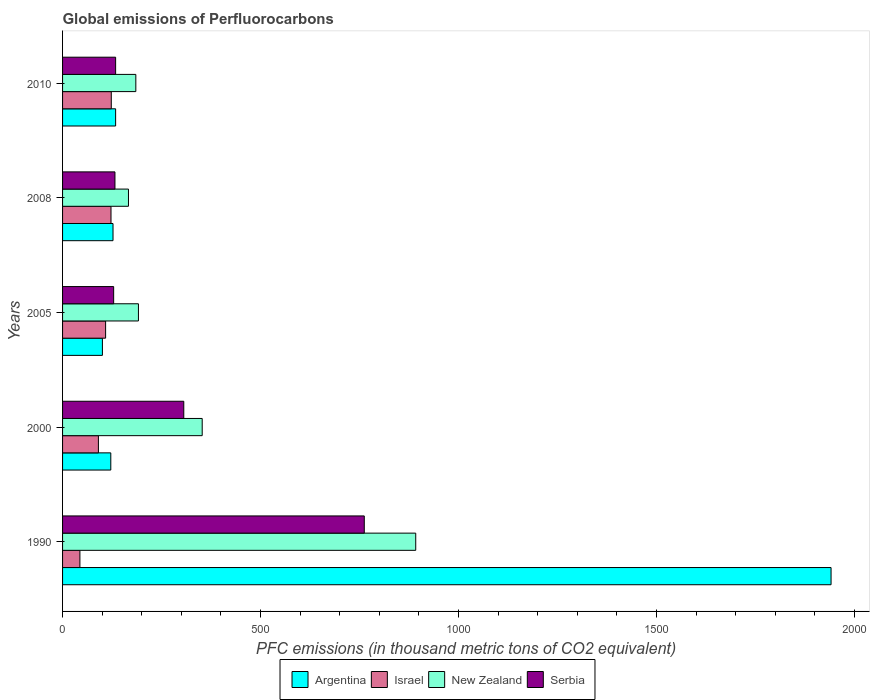Are the number of bars on each tick of the Y-axis equal?
Provide a short and direct response. Yes. What is the label of the 3rd group of bars from the top?
Give a very brief answer. 2005. What is the global emissions of Perfluorocarbons in New Zealand in 2000?
Your answer should be compact. 352.6. Across all years, what is the maximum global emissions of Perfluorocarbons in Argentina?
Make the answer very short. 1940.6. Across all years, what is the minimum global emissions of Perfluorocarbons in New Zealand?
Make the answer very short. 166.4. In which year was the global emissions of Perfluorocarbons in Serbia minimum?
Provide a succinct answer. 2005. What is the total global emissions of Perfluorocarbons in Argentina in the graph?
Keep it short and to the point. 2424.4. What is the difference between the global emissions of Perfluorocarbons in New Zealand in 2008 and that in 2010?
Your answer should be very brief. -18.6. What is the difference between the global emissions of Perfluorocarbons in Israel in 1990 and the global emissions of Perfluorocarbons in New Zealand in 2010?
Ensure brevity in your answer.  -141.2. What is the average global emissions of Perfluorocarbons in Serbia per year?
Offer a terse response. 292.66. In the year 2005, what is the difference between the global emissions of Perfluorocarbons in Serbia and global emissions of Perfluorocarbons in Israel?
Give a very brief answer. 20.3. What is the ratio of the global emissions of Perfluorocarbons in Israel in 2000 to that in 2010?
Keep it short and to the point. 0.74. What is the difference between the highest and the second highest global emissions of Perfluorocarbons in Argentina?
Your answer should be compact. 1806.6. What is the difference between the highest and the lowest global emissions of Perfluorocarbons in New Zealand?
Provide a short and direct response. 725.4. Is it the case that in every year, the sum of the global emissions of Perfluorocarbons in Israel and global emissions of Perfluorocarbons in Argentina is greater than the sum of global emissions of Perfluorocarbons in New Zealand and global emissions of Perfluorocarbons in Serbia?
Give a very brief answer. No. What does the 1st bar from the top in 2010 represents?
Offer a terse response. Serbia. Are all the bars in the graph horizontal?
Provide a short and direct response. Yes. How many years are there in the graph?
Provide a succinct answer. 5. Are the values on the major ticks of X-axis written in scientific E-notation?
Your answer should be very brief. No. Does the graph contain any zero values?
Your answer should be compact. No. Does the graph contain grids?
Offer a very short reply. No. Where does the legend appear in the graph?
Ensure brevity in your answer.  Bottom center. How many legend labels are there?
Offer a terse response. 4. How are the legend labels stacked?
Provide a succinct answer. Horizontal. What is the title of the graph?
Offer a terse response. Global emissions of Perfluorocarbons. Does "Uruguay" appear as one of the legend labels in the graph?
Your response must be concise. No. What is the label or title of the X-axis?
Keep it short and to the point. PFC emissions (in thousand metric tons of CO2 equivalent). What is the PFC emissions (in thousand metric tons of CO2 equivalent) of Argentina in 1990?
Provide a succinct answer. 1940.6. What is the PFC emissions (in thousand metric tons of CO2 equivalent) in Israel in 1990?
Provide a succinct answer. 43.8. What is the PFC emissions (in thousand metric tons of CO2 equivalent) in New Zealand in 1990?
Your response must be concise. 891.8. What is the PFC emissions (in thousand metric tons of CO2 equivalent) in Serbia in 1990?
Provide a succinct answer. 761.9. What is the PFC emissions (in thousand metric tons of CO2 equivalent) of Argentina in 2000?
Offer a terse response. 121.8. What is the PFC emissions (in thousand metric tons of CO2 equivalent) in Israel in 2000?
Make the answer very short. 90.5. What is the PFC emissions (in thousand metric tons of CO2 equivalent) in New Zealand in 2000?
Your answer should be compact. 352.6. What is the PFC emissions (in thousand metric tons of CO2 equivalent) of Serbia in 2000?
Make the answer very short. 306.1. What is the PFC emissions (in thousand metric tons of CO2 equivalent) in Argentina in 2005?
Provide a short and direct response. 100.6. What is the PFC emissions (in thousand metric tons of CO2 equivalent) in Israel in 2005?
Ensure brevity in your answer.  108.7. What is the PFC emissions (in thousand metric tons of CO2 equivalent) of New Zealand in 2005?
Offer a terse response. 191.6. What is the PFC emissions (in thousand metric tons of CO2 equivalent) of Serbia in 2005?
Your response must be concise. 129. What is the PFC emissions (in thousand metric tons of CO2 equivalent) of Argentina in 2008?
Keep it short and to the point. 127.4. What is the PFC emissions (in thousand metric tons of CO2 equivalent) in Israel in 2008?
Your answer should be very brief. 122.3. What is the PFC emissions (in thousand metric tons of CO2 equivalent) in New Zealand in 2008?
Offer a terse response. 166.4. What is the PFC emissions (in thousand metric tons of CO2 equivalent) in Serbia in 2008?
Provide a succinct answer. 132.3. What is the PFC emissions (in thousand metric tons of CO2 equivalent) of Argentina in 2010?
Give a very brief answer. 134. What is the PFC emissions (in thousand metric tons of CO2 equivalent) in Israel in 2010?
Offer a very short reply. 123. What is the PFC emissions (in thousand metric tons of CO2 equivalent) of New Zealand in 2010?
Keep it short and to the point. 185. What is the PFC emissions (in thousand metric tons of CO2 equivalent) in Serbia in 2010?
Offer a very short reply. 134. Across all years, what is the maximum PFC emissions (in thousand metric tons of CO2 equivalent) of Argentina?
Give a very brief answer. 1940.6. Across all years, what is the maximum PFC emissions (in thousand metric tons of CO2 equivalent) in Israel?
Ensure brevity in your answer.  123. Across all years, what is the maximum PFC emissions (in thousand metric tons of CO2 equivalent) of New Zealand?
Provide a short and direct response. 891.8. Across all years, what is the maximum PFC emissions (in thousand metric tons of CO2 equivalent) in Serbia?
Offer a terse response. 761.9. Across all years, what is the minimum PFC emissions (in thousand metric tons of CO2 equivalent) of Argentina?
Provide a short and direct response. 100.6. Across all years, what is the minimum PFC emissions (in thousand metric tons of CO2 equivalent) of Israel?
Give a very brief answer. 43.8. Across all years, what is the minimum PFC emissions (in thousand metric tons of CO2 equivalent) of New Zealand?
Your answer should be compact. 166.4. Across all years, what is the minimum PFC emissions (in thousand metric tons of CO2 equivalent) of Serbia?
Provide a succinct answer. 129. What is the total PFC emissions (in thousand metric tons of CO2 equivalent) in Argentina in the graph?
Your response must be concise. 2424.4. What is the total PFC emissions (in thousand metric tons of CO2 equivalent) in Israel in the graph?
Keep it short and to the point. 488.3. What is the total PFC emissions (in thousand metric tons of CO2 equivalent) of New Zealand in the graph?
Provide a succinct answer. 1787.4. What is the total PFC emissions (in thousand metric tons of CO2 equivalent) of Serbia in the graph?
Your response must be concise. 1463.3. What is the difference between the PFC emissions (in thousand metric tons of CO2 equivalent) of Argentina in 1990 and that in 2000?
Keep it short and to the point. 1818.8. What is the difference between the PFC emissions (in thousand metric tons of CO2 equivalent) in Israel in 1990 and that in 2000?
Give a very brief answer. -46.7. What is the difference between the PFC emissions (in thousand metric tons of CO2 equivalent) of New Zealand in 1990 and that in 2000?
Ensure brevity in your answer.  539.2. What is the difference between the PFC emissions (in thousand metric tons of CO2 equivalent) in Serbia in 1990 and that in 2000?
Your response must be concise. 455.8. What is the difference between the PFC emissions (in thousand metric tons of CO2 equivalent) of Argentina in 1990 and that in 2005?
Give a very brief answer. 1840. What is the difference between the PFC emissions (in thousand metric tons of CO2 equivalent) of Israel in 1990 and that in 2005?
Offer a terse response. -64.9. What is the difference between the PFC emissions (in thousand metric tons of CO2 equivalent) in New Zealand in 1990 and that in 2005?
Keep it short and to the point. 700.2. What is the difference between the PFC emissions (in thousand metric tons of CO2 equivalent) in Serbia in 1990 and that in 2005?
Your response must be concise. 632.9. What is the difference between the PFC emissions (in thousand metric tons of CO2 equivalent) in Argentina in 1990 and that in 2008?
Offer a very short reply. 1813.2. What is the difference between the PFC emissions (in thousand metric tons of CO2 equivalent) in Israel in 1990 and that in 2008?
Your answer should be compact. -78.5. What is the difference between the PFC emissions (in thousand metric tons of CO2 equivalent) in New Zealand in 1990 and that in 2008?
Keep it short and to the point. 725.4. What is the difference between the PFC emissions (in thousand metric tons of CO2 equivalent) of Serbia in 1990 and that in 2008?
Provide a short and direct response. 629.6. What is the difference between the PFC emissions (in thousand metric tons of CO2 equivalent) in Argentina in 1990 and that in 2010?
Your answer should be compact. 1806.6. What is the difference between the PFC emissions (in thousand metric tons of CO2 equivalent) in Israel in 1990 and that in 2010?
Keep it short and to the point. -79.2. What is the difference between the PFC emissions (in thousand metric tons of CO2 equivalent) in New Zealand in 1990 and that in 2010?
Provide a succinct answer. 706.8. What is the difference between the PFC emissions (in thousand metric tons of CO2 equivalent) in Serbia in 1990 and that in 2010?
Offer a terse response. 627.9. What is the difference between the PFC emissions (in thousand metric tons of CO2 equivalent) in Argentina in 2000 and that in 2005?
Provide a succinct answer. 21.2. What is the difference between the PFC emissions (in thousand metric tons of CO2 equivalent) of Israel in 2000 and that in 2005?
Offer a very short reply. -18.2. What is the difference between the PFC emissions (in thousand metric tons of CO2 equivalent) of New Zealand in 2000 and that in 2005?
Keep it short and to the point. 161. What is the difference between the PFC emissions (in thousand metric tons of CO2 equivalent) in Serbia in 2000 and that in 2005?
Ensure brevity in your answer.  177.1. What is the difference between the PFC emissions (in thousand metric tons of CO2 equivalent) of Israel in 2000 and that in 2008?
Give a very brief answer. -31.8. What is the difference between the PFC emissions (in thousand metric tons of CO2 equivalent) in New Zealand in 2000 and that in 2008?
Your answer should be very brief. 186.2. What is the difference between the PFC emissions (in thousand metric tons of CO2 equivalent) of Serbia in 2000 and that in 2008?
Make the answer very short. 173.8. What is the difference between the PFC emissions (in thousand metric tons of CO2 equivalent) in Israel in 2000 and that in 2010?
Your answer should be very brief. -32.5. What is the difference between the PFC emissions (in thousand metric tons of CO2 equivalent) of New Zealand in 2000 and that in 2010?
Keep it short and to the point. 167.6. What is the difference between the PFC emissions (in thousand metric tons of CO2 equivalent) of Serbia in 2000 and that in 2010?
Your response must be concise. 172.1. What is the difference between the PFC emissions (in thousand metric tons of CO2 equivalent) in Argentina in 2005 and that in 2008?
Provide a succinct answer. -26.8. What is the difference between the PFC emissions (in thousand metric tons of CO2 equivalent) in New Zealand in 2005 and that in 2008?
Keep it short and to the point. 25.2. What is the difference between the PFC emissions (in thousand metric tons of CO2 equivalent) in Argentina in 2005 and that in 2010?
Provide a succinct answer. -33.4. What is the difference between the PFC emissions (in thousand metric tons of CO2 equivalent) of Israel in 2005 and that in 2010?
Keep it short and to the point. -14.3. What is the difference between the PFC emissions (in thousand metric tons of CO2 equivalent) in New Zealand in 2005 and that in 2010?
Keep it short and to the point. 6.6. What is the difference between the PFC emissions (in thousand metric tons of CO2 equivalent) of Serbia in 2005 and that in 2010?
Provide a short and direct response. -5. What is the difference between the PFC emissions (in thousand metric tons of CO2 equivalent) of Argentina in 2008 and that in 2010?
Keep it short and to the point. -6.6. What is the difference between the PFC emissions (in thousand metric tons of CO2 equivalent) of Israel in 2008 and that in 2010?
Your answer should be very brief. -0.7. What is the difference between the PFC emissions (in thousand metric tons of CO2 equivalent) in New Zealand in 2008 and that in 2010?
Offer a very short reply. -18.6. What is the difference between the PFC emissions (in thousand metric tons of CO2 equivalent) of Argentina in 1990 and the PFC emissions (in thousand metric tons of CO2 equivalent) of Israel in 2000?
Offer a very short reply. 1850.1. What is the difference between the PFC emissions (in thousand metric tons of CO2 equivalent) of Argentina in 1990 and the PFC emissions (in thousand metric tons of CO2 equivalent) of New Zealand in 2000?
Your answer should be compact. 1588. What is the difference between the PFC emissions (in thousand metric tons of CO2 equivalent) in Argentina in 1990 and the PFC emissions (in thousand metric tons of CO2 equivalent) in Serbia in 2000?
Offer a very short reply. 1634.5. What is the difference between the PFC emissions (in thousand metric tons of CO2 equivalent) of Israel in 1990 and the PFC emissions (in thousand metric tons of CO2 equivalent) of New Zealand in 2000?
Provide a short and direct response. -308.8. What is the difference between the PFC emissions (in thousand metric tons of CO2 equivalent) of Israel in 1990 and the PFC emissions (in thousand metric tons of CO2 equivalent) of Serbia in 2000?
Your answer should be very brief. -262.3. What is the difference between the PFC emissions (in thousand metric tons of CO2 equivalent) in New Zealand in 1990 and the PFC emissions (in thousand metric tons of CO2 equivalent) in Serbia in 2000?
Provide a short and direct response. 585.7. What is the difference between the PFC emissions (in thousand metric tons of CO2 equivalent) of Argentina in 1990 and the PFC emissions (in thousand metric tons of CO2 equivalent) of Israel in 2005?
Keep it short and to the point. 1831.9. What is the difference between the PFC emissions (in thousand metric tons of CO2 equivalent) of Argentina in 1990 and the PFC emissions (in thousand metric tons of CO2 equivalent) of New Zealand in 2005?
Your answer should be compact. 1749. What is the difference between the PFC emissions (in thousand metric tons of CO2 equivalent) of Argentina in 1990 and the PFC emissions (in thousand metric tons of CO2 equivalent) of Serbia in 2005?
Provide a succinct answer. 1811.6. What is the difference between the PFC emissions (in thousand metric tons of CO2 equivalent) of Israel in 1990 and the PFC emissions (in thousand metric tons of CO2 equivalent) of New Zealand in 2005?
Keep it short and to the point. -147.8. What is the difference between the PFC emissions (in thousand metric tons of CO2 equivalent) of Israel in 1990 and the PFC emissions (in thousand metric tons of CO2 equivalent) of Serbia in 2005?
Your answer should be very brief. -85.2. What is the difference between the PFC emissions (in thousand metric tons of CO2 equivalent) in New Zealand in 1990 and the PFC emissions (in thousand metric tons of CO2 equivalent) in Serbia in 2005?
Provide a succinct answer. 762.8. What is the difference between the PFC emissions (in thousand metric tons of CO2 equivalent) in Argentina in 1990 and the PFC emissions (in thousand metric tons of CO2 equivalent) in Israel in 2008?
Your response must be concise. 1818.3. What is the difference between the PFC emissions (in thousand metric tons of CO2 equivalent) in Argentina in 1990 and the PFC emissions (in thousand metric tons of CO2 equivalent) in New Zealand in 2008?
Offer a very short reply. 1774.2. What is the difference between the PFC emissions (in thousand metric tons of CO2 equivalent) of Argentina in 1990 and the PFC emissions (in thousand metric tons of CO2 equivalent) of Serbia in 2008?
Give a very brief answer. 1808.3. What is the difference between the PFC emissions (in thousand metric tons of CO2 equivalent) in Israel in 1990 and the PFC emissions (in thousand metric tons of CO2 equivalent) in New Zealand in 2008?
Give a very brief answer. -122.6. What is the difference between the PFC emissions (in thousand metric tons of CO2 equivalent) of Israel in 1990 and the PFC emissions (in thousand metric tons of CO2 equivalent) of Serbia in 2008?
Your answer should be compact. -88.5. What is the difference between the PFC emissions (in thousand metric tons of CO2 equivalent) of New Zealand in 1990 and the PFC emissions (in thousand metric tons of CO2 equivalent) of Serbia in 2008?
Your response must be concise. 759.5. What is the difference between the PFC emissions (in thousand metric tons of CO2 equivalent) of Argentina in 1990 and the PFC emissions (in thousand metric tons of CO2 equivalent) of Israel in 2010?
Your answer should be very brief. 1817.6. What is the difference between the PFC emissions (in thousand metric tons of CO2 equivalent) of Argentina in 1990 and the PFC emissions (in thousand metric tons of CO2 equivalent) of New Zealand in 2010?
Ensure brevity in your answer.  1755.6. What is the difference between the PFC emissions (in thousand metric tons of CO2 equivalent) in Argentina in 1990 and the PFC emissions (in thousand metric tons of CO2 equivalent) in Serbia in 2010?
Provide a short and direct response. 1806.6. What is the difference between the PFC emissions (in thousand metric tons of CO2 equivalent) of Israel in 1990 and the PFC emissions (in thousand metric tons of CO2 equivalent) of New Zealand in 2010?
Ensure brevity in your answer.  -141.2. What is the difference between the PFC emissions (in thousand metric tons of CO2 equivalent) in Israel in 1990 and the PFC emissions (in thousand metric tons of CO2 equivalent) in Serbia in 2010?
Your answer should be very brief. -90.2. What is the difference between the PFC emissions (in thousand metric tons of CO2 equivalent) in New Zealand in 1990 and the PFC emissions (in thousand metric tons of CO2 equivalent) in Serbia in 2010?
Provide a succinct answer. 757.8. What is the difference between the PFC emissions (in thousand metric tons of CO2 equivalent) in Argentina in 2000 and the PFC emissions (in thousand metric tons of CO2 equivalent) in Israel in 2005?
Your response must be concise. 13.1. What is the difference between the PFC emissions (in thousand metric tons of CO2 equivalent) of Argentina in 2000 and the PFC emissions (in thousand metric tons of CO2 equivalent) of New Zealand in 2005?
Offer a very short reply. -69.8. What is the difference between the PFC emissions (in thousand metric tons of CO2 equivalent) in Israel in 2000 and the PFC emissions (in thousand metric tons of CO2 equivalent) in New Zealand in 2005?
Offer a terse response. -101.1. What is the difference between the PFC emissions (in thousand metric tons of CO2 equivalent) of Israel in 2000 and the PFC emissions (in thousand metric tons of CO2 equivalent) of Serbia in 2005?
Provide a succinct answer. -38.5. What is the difference between the PFC emissions (in thousand metric tons of CO2 equivalent) in New Zealand in 2000 and the PFC emissions (in thousand metric tons of CO2 equivalent) in Serbia in 2005?
Give a very brief answer. 223.6. What is the difference between the PFC emissions (in thousand metric tons of CO2 equivalent) in Argentina in 2000 and the PFC emissions (in thousand metric tons of CO2 equivalent) in New Zealand in 2008?
Provide a short and direct response. -44.6. What is the difference between the PFC emissions (in thousand metric tons of CO2 equivalent) of Argentina in 2000 and the PFC emissions (in thousand metric tons of CO2 equivalent) of Serbia in 2008?
Offer a very short reply. -10.5. What is the difference between the PFC emissions (in thousand metric tons of CO2 equivalent) in Israel in 2000 and the PFC emissions (in thousand metric tons of CO2 equivalent) in New Zealand in 2008?
Provide a short and direct response. -75.9. What is the difference between the PFC emissions (in thousand metric tons of CO2 equivalent) of Israel in 2000 and the PFC emissions (in thousand metric tons of CO2 equivalent) of Serbia in 2008?
Make the answer very short. -41.8. What is the difference between the PFC emissions (in thousand metric tons of CO2 equivalent) of New Zealand in 2000 and the PFC emissions (in thousand metric tons of CO2 equivalent) of Serbia in 2008?
Provide a short and direct response. 220.3. What is the difference between the PFC emissions (in thousand metric tons of CO2 equivalent) in Argentina in 2000 and the PFC emissions (in thousand metric tons of CO2 equivalent) in New Zealand in 2010?
Provide a succinct answer. -63.2. What is the difference between the PFC emissions (in thousand metric tons of CO2 equivalent) of Israel in 2000 and the PFC emissions (in thousand metric tons of CO2 equivalent) of New Zealand in 2010?
Your response must be concise. -94.5. What is the difference between the PFC emissions (in thousand metric tons of CO2 equivalent) of Israel in 2000 and the PFC emissions (in thousand metric tons of CO2 equivalent) of Serbia in 2010?
Your answer should be very brief. -43.5. What is the difference between the PFC emissions (in thousand metric tons of CO2 equivalent) in New Zealand in 2000 and the PFC emissions (in thousand metric tons of CO2 equivalent) in Serbia in 2010?
Your response must be concise. 218.6. What is the difference between the PFC emissions (in thousand metric tons of CO2 equivalent) of Argentina in 2005 and the PFC emissions (in thousand metric tons of CO2 equivalent) of Israel in 2008?
Give a very brief answer. -21.7. What is the difference between the PFC emissions (in thousand metric tons of CO2 equivalent) of Argentina in 2005 and the PFC emissions (in thousand metric tons of CO2 equivalent) of New Zealand in 2008?
Give a very brief answer. -65.8. What is the difference between the PFC emissions (in thousand metric tons of CO2 equivalent) of Argentina in 2005 and the PFC emissions (in thousand metric tons of CO2 equivalent) of Serbia in 2008?
Your answer should be compact. -31.7. What is the difference between the PFC emissions (in thousand metric tons of CO2 equivalent) in Israel in 2005 and the PFC emissions (in thousand metric tons of CO2 equivalent) in New Zealand in 2008?
Provide a short and direct response. -57.7. What is the difference between the PFC emissions (in thousand metric tons of CO2 equivalent) in Israel in 2005 and the PFC emissions (in thousand metric tons of CO2 equivalent) in Serbia in 2008?
Provide a short and direct response. -23.6. What is the difference between the PFC emissions (in thousand metric tons of CO2 equivalent) in New Zealand in 2005 and the PFC emissions (in thousand metric tons of CO2 equivalent) in Serbia in 2008?
Provide a succinct answer. 59.3. What is the difference between the PFC emissions (in thousand metric tons of CO2 equivalent) of Argentina in 2005 and the PFC emissions (in thousand metric tons of CO2 equivalent) of Israel in 2010?
Ensure brevity in your answer.  -22.4. What is the difference between the PFC emissions (in thousand metric tons of CO2 equivalent) in Argentina in 2005 and the PFC emissions (in thousand metric tons of CO2 equivalent) in New Zealand in 2010?
Your response must be concise. -84.4. What is the difference between the PFC emissions (in thousand metric tons of CO2 equivalent) of Argentina in 2005 and the PFC emissions (in thousand metric tons of CO2 equivalent) of Serbia in 2010?
Provide a succinct answer. -33.4. What is the difference between the PFC emissions (in thousand metric tons of CO2 equivalent) of Israel in 2005 and the PFC emissions (in thousand metric tons of CO2 equivalent) of New Zealand in 2010?
Make the answer very short. -76.3. What is the difference between the PFC emissions (in thousand metric tons of CO2 equivalent) of Israel in 2005 and the PFC emissions (in thousand metric tons of CO2 equivalent) of Serbia in 2010?
Offer a terse response. -25.3. What is the difference between the PFC emissions (in thousand metric tons of CO2 equivalent) in New Zealand in 2005 and the PFC emissions (in thousand metric tons of CO2 equivalent) in Serbia in 2010?
Your response must be concise. 57.6. What is the difference between the PFC emissions (in thousand metric tons of CO2 equivalent) of Argentina in 2008 and the PFC emissions (in thousand metric tons of CO2 equivalent) of New Zealand in 2010?
Provide a succinct answer. -57.6. What is the difference between the PFC emissions (in thousand metric tons of CO2 equivalent) in Argentina in 2008 and the PFC emissions (in thousand metric tons of CO2 equivalent) in Serbia in 2010?
Offer a very short reply. -6.6. What is the difference between the PFC emissions (in thousand metric tons of CO2 equivalent) of Israel in 2008 and the PFC emissions (in thousand metric tons of CO2 equivalent) of New Zealand in 2010?
Keep it short and to the point. -62.7. What is the difference between the PFC emissions (in thousand metric tons of CO2 equivalent) in New Zealand in 2008 and the PFC emissions (in thousand metric tons of CO2 equivalent) in Serbia in 2010?
Your answer should be very brief. 32.4. What is the average PFC emissions (in thousand metric tons of CO2 equivalent) in Argentina per year?
Ensure brevity in your answer.  484.88. What is the average PFC emissions (in thousand metric tons of CO2 equivalent) in Israel per year?
Your answer should be very brief. 97.66. What is the average PFC emissions (in thousand metric tons of CO2 equivalent) in New Zealand per year?
Your answer should be very brief. 357.48. What is the average PFC emissions (in thousand metric tons of CO2 equivalent) of Serbia per year?
Offer a terse response. 292.66. In the year 1990, what is the difference between the PFC emissions (in thousand metric tons of CO2 equivalent) of Argentina and PFC emissions (in thousand metric tons of CO2 equivalent) of Israel?
Keep it short and to the point. 1896.8. In the year 1990, what is the difference between the PFC emissions (in thousand metric tons of CO2 equivalent) in Argentina and PFC emissions (in thousand metric tons of CO2 equivalent) in New Zealand?
Make the answer very short. 1048.8. In the year 1990, what is the difference between the PFC emissions (in thousand metric tons of CO2 equivalent) in Argentina and PFC emissions (in thousand metric tons of CO2 equivalent) in Serbia?
Provide a short and direct response. 1178.7. In the year 1990, what is the difference between the PFC emissions (in thousand metric tons of CO2 equivalent) of Israel and PFC emissions (in thousand metric tons of CO2 equivalent) of New Zealand?
Your answer should be very brief. -848. In the year 1990, what is the difference between the PFC emissions (in thousand metric tons of CO2 equivalent) of Israel and PFC emissions (in thousand metric tons of CO2 equivalent) of Serbia?
Your answer should be very brief. -718.1. In the year 1990, what is the difference between the PFC emissions (in thousand metric tons of CO2 equivalent) of New Zealand and PFC emissions (in thousand metric tons of CO2 equivalent) of Serbia?
Make the answer very short. 129.9. In the year 2000, what is the difference between the PFC emissions (in thousand metric tons of CO2 equivalent) in Argentina and PFC emissions (in thousand metric tons of CO2 equivalent) in Israel?
Your answer should be very brief. 31.3. In the year 2000, what is the difference between the PFC emissions (in thousand metric tons of CO2 equivalent) of Argentina and PFC emissions (in thousand metric tons of CO2 equivalent) of New Zealand?
Provide a short and direct response. -230.8. In the year 2000, what is the difference between the PFC emissions (in thousand metric tons of CO2 equivalent) of Argentina and PFC emissions (in thousand metric tons of CO2 equivalent) of Serbia?
Your response must be concise. -184.3. In the year 2000, what is the difference between the PFC emissions (in thousand metric tons of CO2 equivalent) of Israel and PFC emissions (in thousand metric tons of CO2 equivalent) of New Zealand?
Your answer should be very brief. -262.1. In the year 2000, what is the difference between the PFC emissions (in thousand metric tons of CO2 equivalent) of Israel and PFC emissions (in thousand metric tons of CO2 equivalent) of Serbia?
Your answer should be compact. -215.6. In the year 2000, what is the difference between the PFC emissions (in thousand metric tons of CO2 equivalent) of New Zealand and PFC emissions (in thousand metric tons of CO2 equivalent) of Serbia?
Make the answer very short. 46.5. In the year 2005, what is the difference between the PFC emissions (in thousand metric tons of CO2 equivalent) of Argentina and PFC emissions (in thousand metric tons of CO2 equivalent) of New Zealand?
Provide a succinct answer. -91. In the year 2005, what is the difference between the PFC emissions (in thousand metric tons of CO2 equivalent) of Argentina and PFC emissions (in thousand metric tons of CO2 equivalent) of Serbia?
Provide a succinct answer. -28.4. In the year 2005, what is the difference between the PFC emissions (in thousand metric tons of CO2 equivalent) in Israel and PFC emissions (in thousand metric tons of CO2 equivalent) in New Zealand?
Provide a short and direct response. -82.9. In the year 2005, what is the difference between the PFC emissions (in thousand metric tons of CO2 equivalent) of Israel and PFC emissions (in thousand metric tons of CO2 equivalent) of Serbia?
Give a very brief answer. -20.3. In the year 2005, what is the difference between the PFC emissions (in thousand metric tons of CO2 equivalent) of New Zealand and PFC emissions (in thousand metric tons of CO2 equivalent) of Serbia?
Ensure brevity in your answer.  62.6. In the year 2008, what is the difference between the PFC emissions (in thousand metric tons of CO2 equivalent) in Argentina and PFC emissions (in thousand metric tons of CO2 equivalent) in Israel?
Your answer should be compact. 5.1. In the year 2008, what is the difference between the PFC emissions (in thousand metric tons of CO2 equivalent) of Argentina and PFC emissions (in thousand metric tons of CO2 equivalent) of New Zealand?
Keep it short and to the point. -39. In the year 2008, what is the difference between the PFC emissions (in thousand metric tons of CO2 equivalent) of Argentina and PFC emissions (in thousand metric tons of CO2 equivalent) of Serbia?
Offer a terse response. -4.9. In the year 2008, what is the difference between the PFC emissions (in thousand metric tons of CO2 equivalent) of Israel and PFC emissions (in thousand metric tons of CO2 equivalent) of New Zealand?
Provide a succinct answer. -44.1. In the year 2008, what is the difference between the PFC emissions (in thousand metric tons of CO2 equivalent) of New Zealand and PFC emissions (in thousand metric tons of CO2 equivalent) of Serbia?
Your answer should be compact. 34.1. In the year 2010, what is the difference between the PFC emissions (in thousand metric tons of CO2 equivalent) of Argentina and PFC emissions (in thousand metric tons of CO2 equivalent) of Israel?
Your answer should be very brief. 11. In the year 2010, what is the difference between the PFC emissions (in thousand metric tons of CO2 equivalent) in Argentina and PFC emissions (in thousand metric tons of CO2 equivalent) in New Zealand?
Provide a succinct answer. -51. In the year 2010, what is the difference between the PFC emissions (in thousand metric tons of CO2 equivalent) in Israel and PFC emissions (in thousand metric tons of CO2 equivalent) in New Zealand?
Ensure brevity in your answer.  -62. What is the ratio of the PFC emissions (in thousand metric tons of CO2 equivalent) of Argentina in 1990 to that in 2000?
Provide a short and direct response. 15.93. What is the ratio of the PFC emissions (in thousand metric tons of CO2 equivalent) of Israel in 1990 to that in 2000?
Offer a very short reply. 0.48. What is the ratio of the PFC emissions (in thousand metric tons of CO2 equivalent) in New Zealand in 1990 to that in 2000?
Give a very brief answer. 2.53. What is the ratio of the PFC emissions (in thousand metric tons of CO2 equivalent) of Serbia in 1990 to that in 2000?
Your answer should be compact. 2.49. What is the ratio of the PFC emissions (in thousand metric tons of CO2 equivalent) in Argentina in 1990 to that in 2005?
Make the answer very short. 19.29. What is the ratio of the PFC emissions (in thousand metric tons of CO2 equivalent) of Israel in 1990 to that in 2005?
Offer a terse response. 0.4. What is the ratio of the PFC emissions (in thousand metric tons of CO2 equivalent) of New Zealand in 1990 to that in 2005?
Your answer should be very brief. 4.65. What is the ratio of the PFC emissions (in thousand metric tons of CO2 equivalent) of Serbia in 1990 to that in 2005?
Provide a succinct answer. 5.91. What is the ratio of the PFC emissions (in thousand metric tons of CO2 equivalent) of Argentina in 1990 to that in 2008?
Provide a succinct answer. 15.23. What is the ratio of the PFC emissions (in thousand metric tons of CO2 equivalent) of Israel in 1990 to that in 2008?
Your answer should be very brief. 0.36. What is the ratio of the PFC emissions (in thousand metric tons of CO2 equivalent) in New Zealand in 1990 to that in 2008?
Offer a terse response. 5.36. What is the ratio of the PFC emissions (in thousand metric tons of CO2 equivalent) in Serbia in 1990 to that in 2008?
Make the answer very short. 5.76. What is the ratio of the PFC emissions (in thousand metric tons of CO2 equivalent) of Argentina in 1990 to that in 2010?
Your answer should be compact. 14.48. What is the ratio of the PFC emissions (in thousand metric tons of CO2 equivalent) in Israel in 1990 to that in 2010?
Offer a very short reply. 0.36. What is the ratio of the PFC emissions (in thousand metric tons of CO2 equivalent) in New Zealand in 1990 to that in 2010?
Keep it short and to the point. 4.82. What is the ratio of the PFC emissions (in thousand metric tons of CO2 equivalent) of Serbia in 1990 to that in 2010?
Offer a very short reply. 5.69. What is the ratio of the PFC emissions (in thousand metric tons of CO2 equivalent) in Argentina in 2000 to that in 2005?
Give a very brief answer. 1.21. What is the ratio of the PFC emissions (in thousand metric tons of CO2 equivalent) of Israel in 2000 to that in 2005?
Ensure brevity in your answer.  0.83. What is the ratio of the PFC emissions (in thousand metric tons of CO2 equivalent) in New Zealand in 2000 to that in 2005?
Make the answer very short. 1.84. What is the ratio of the PFC emissions (in thousand metric tons of CO2 equivalent) of Serbia in 2000 to that in 2005?
Offer a very short reply. 2.37. What is the ratio of the PFC emissions (in thousand metric tons of CO2 equivalent) in Argentina in 2000 to that in 2008?
Ensure brevity in your answer.  0.96. What is the ratio of the PFC emissions (in thousand metric tons of CO2 equivalent) of Israel in 2000 to that in 2008?
Keep it short and to the point. 0.74. What is the ratio of the PFC emissions (in thousand metric tons of CO2 equivalent) in New Zealand in 2000 to that in 2008?
Give a very brief answer. 2.12. What is the ratio of the PFC emissions (in thousand metric tons of CO2 equivalent) in Serbia in 2000 to that in 2008?
Offer a very short reply. 2.31. What is the ratio of the PFC emissions (in thousand metric tons of CO2 equivalent) of Argentina in 2000 to that in 2010?
Give a very brief answer. 0.91. What is the ratio of the PFC emissions (in thousand metric tons of CO2 equivalent) in Israel in 2000 to that in 2010?
Your response must be concise. 0.74. What is the ratio of the PFC emissions (in thousand metric tons of CO2 equivalent) in New Zealand in 2000 to that in 2010?
Keep it short and to the point. 1.91. What is the ratio of the PFC emissions (in thousand metric tons of CO2 equivalent) in Serbia in 2000 to that in 2010?
Your answer should be very brief. 2.28. What is the ratio of the PFC emissions (in thousand metric tons of CO2 equivalent) of Argentina in 2005 to that in 2008?
Your answer should be very brief. 0.79. What is the ratio of the PFC emissions (in thousand metric tons of CO2 equivalent) in Israel in 2005 to that in 2008?
Provide a short and direct response. 0.89. What is the ratio of the PFC emissions (in thousand metric tons of CO2 equivalent) in New Zealand in 2005 to that in 2008?
Provide a short and direct response. 1.15. What is the ratio of the PFC emissions (in thousand metric tons of CO2 equivalent) of Serbia in 2005 to that in 2008?
Give a very brief answer. 0.98. What is the ratio of the PFC emissions (in thousand metric tons of CO2 equivalent) in Argentina in 2005 to that in 2010?
Give a very brief answer. 0.75. What is the ratio of the PFC emissions (in thousand metric tons of CO2 equivalent) of Israel in 2005 to that in 2010?
Ensure brevity in your answer.  0.88. What is the ratio of the PFC emissions (in thousand metric tons of CO2 equivalent) of New Zealand in 2005 to that in 2010?
Offer a very short reply. 1.04. What is the ratio of the PFC emissions (in thousand metric tons of CO2 equivalent) of Serbia in 2005 to that in 2010?
Offer a terse response. 0.96. What is the ratio of the PFC emissions (in thousand metric tons of CO2 equivalent) of Argentina in 2008 to that in 2010?
Keep it short and to the point. 0.95. What is the ratio of the PFC emissions (in thousand metric tons of CO2 equivalent) of Israel in 2008 to that in 2010?
Your answer should be compact. 0.99. What is the ratio of the PFC emissions (in thousand metric tons of CO2 equivalent) of New Zealand in 2008 to that in 2010?
Your answer should be very brief. 0.9. What is the ratio of the PFC emissions (in thousand metric tons of CO2 equivalent) in Serbia in 2008 to that in 2010?
Your answer should be compact. 0.99. What is the difference between the highest and the second highest PFC emissions (in thousand metric tons of CO2 equivalent) in Argentina?
Give a very brief answer. 1806.6. What is the difference between the highest and the second highest PFC emissions (in thousand metric tons of CO2 equivalent) of Israel?
Provide a succinct answer. 0.7. What is the difference between the highest and the second highest PFC emissions (in thousand metric tons of CO2 equivalent) of New Zealand?
Provide a short and direct response. 539.2. What is the difference between the highest and the second highest PFC emissions (in thousand metric tons of CO2 equivalent) of Serbia?
Your answer should be very brief. 455.8. What is the difference between the highest and the lowest PFC emissions (in thousand metric tons of CO2 equivalent) of Argentina?
Ensure brevity in your answer.  1840. What is the difference between the highest and the lowest PFC emissions (in thousand metric tons of CO2 equivalent) in Israel?
Offer a terse response. 79.2. What is the difference between the highest and the lowest PFC emissions (in thousand metric tons of CO2 equivalent) in New Zealand?
Offer a very short reply. 725.4. What is the difference between the highest and the lowest PFC emissions (in thousand metric tons of CO2 equivalent) in Serbia?
Ensure brevity in your answer.  632.9. 